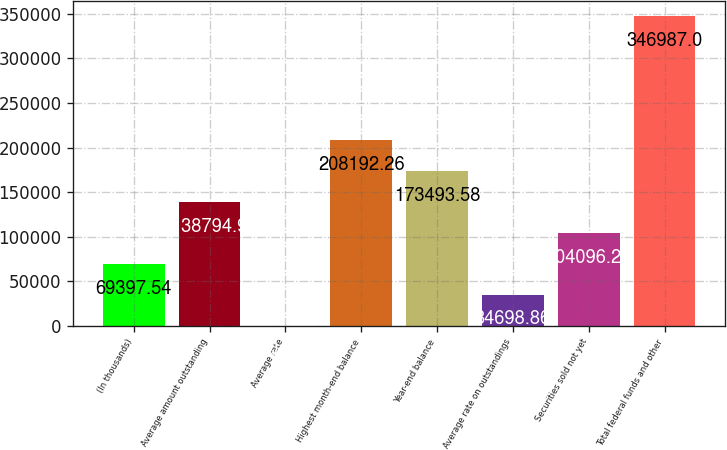<chart> <loc_0><loc_0><loc_500><loc_500><bar_chart><fcel>(In thousands)<fcel>Average amount outstanding<fcel>Average rate<fcel>Highest month-end balance<fcel>Year-end balance<fcel>Average rate on outstandings<fcel>Securities sold not yet<fcel>Total federal funds and other<nl><fcel>69397.5<fcel>138795<fcel>0.18<fcel>208192<fcel>173494<fcel>34698.9<fcel>104096<fcel>346987<nl></chart> 